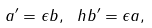Convert formula to latex. <formula><loc_0><loc_0><loc_500><loc_500>a ^ { \prime } = \epsilon b , \ h b ^ { \prime } = \epsilon a ,</formula> 